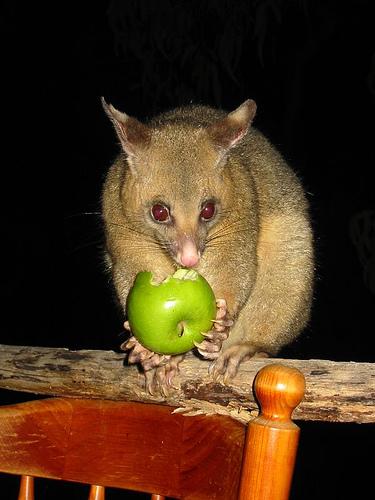What type of food is being shown?
Give a very brief answer. Apple. Is there a chair in the picture?
Be succinct. Yes. What is this animal called?
Short answer required. Rat. 